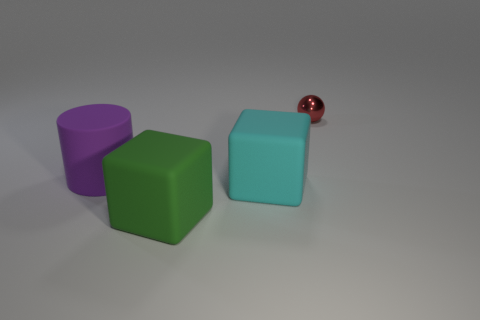Is there anything else that has the same material as the tiny sphere?
Make the answer very short. No. Is the number of tiny red metallic things on the left side of the purple matte thing less than the number of gray cylinders?
Your response must be concise. No. There is another block that is made of the same material as the cyan cube; what is its color?
Provide a short and direct response. Green. There is a metal sphere that is on the right side of the cyan object; what size is it?
Ensure brevity in your answer.  Small. Are the small red thing and the green block made of the same material?
Provide a short and direct response. No. Is there a green rubber thing in front of the big matte block to the right of the big matte object that is in front of the large cyan block?
Your response must be concise. Yes. The metallic sphere is what color?
Offer a very short reply. Red. There is a rubber cylinder that is the same size as the green matte thing; what is its color?
Your response must be concise. Purple. There is a big rubber object right of the big green object; is it the same shape as the tiny red object?
Give a very brief answer. No. There is a rubber block behind the thing in front of the cube that is behind the green rubber block; what color is it?
Offer a very short reply. Cyan. 